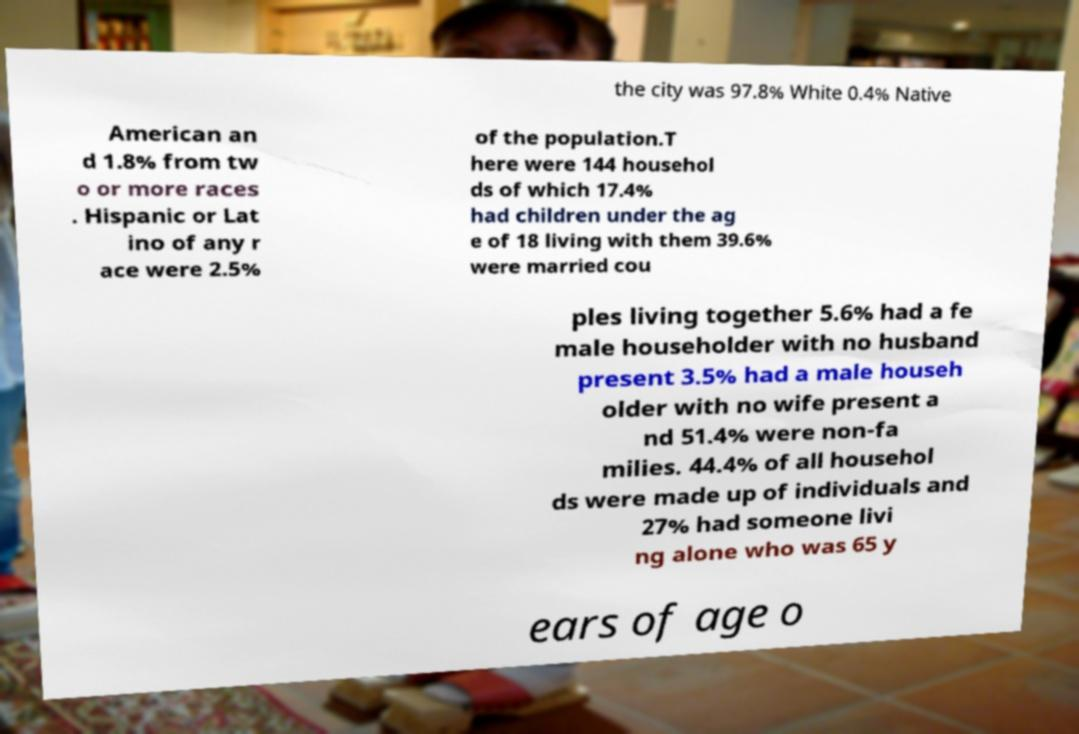Can you read and provide the text displayed in the image?This photo seems to have some interesting text. Can you extract and type it out for me? the city was 97.8% White 0.4% Native American an d 1.8% from tw o or more races . Hispanic or Lat ino of any r ace were 2.5% of the population.T here were 144 househol ds of which 17.4% had children under the ag e of 18 living with them 39.6% were married cou ples living together 5.6% had a fe male householder with no husband present 3.5% had a male househ older with no wife present a nd 51.4% were non-fa milies. 44.4% of all househol ds were made up of individuals and 27% had someone livi ng alone who was 65 y ears of age o 